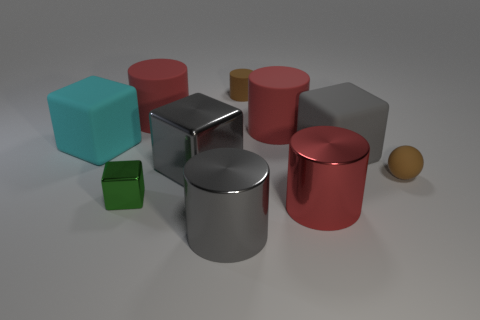Are the materials of the objects in the image the same, and can you describe them? The objects in the image appear to be made from different materials. There are metallic objects that show reflections and shine, such as the silver cylinders, and there are matte objects that could be made of plastic or rubber, like the red and turquoise cubes.  What time of the day does the lighting in the image suggest? The image features a studio lighting setup without natural light, which doesn't indicate a specific time of day. The shadows are soft and diffuse, typical for indoor photography with controlled lighting conditions. 